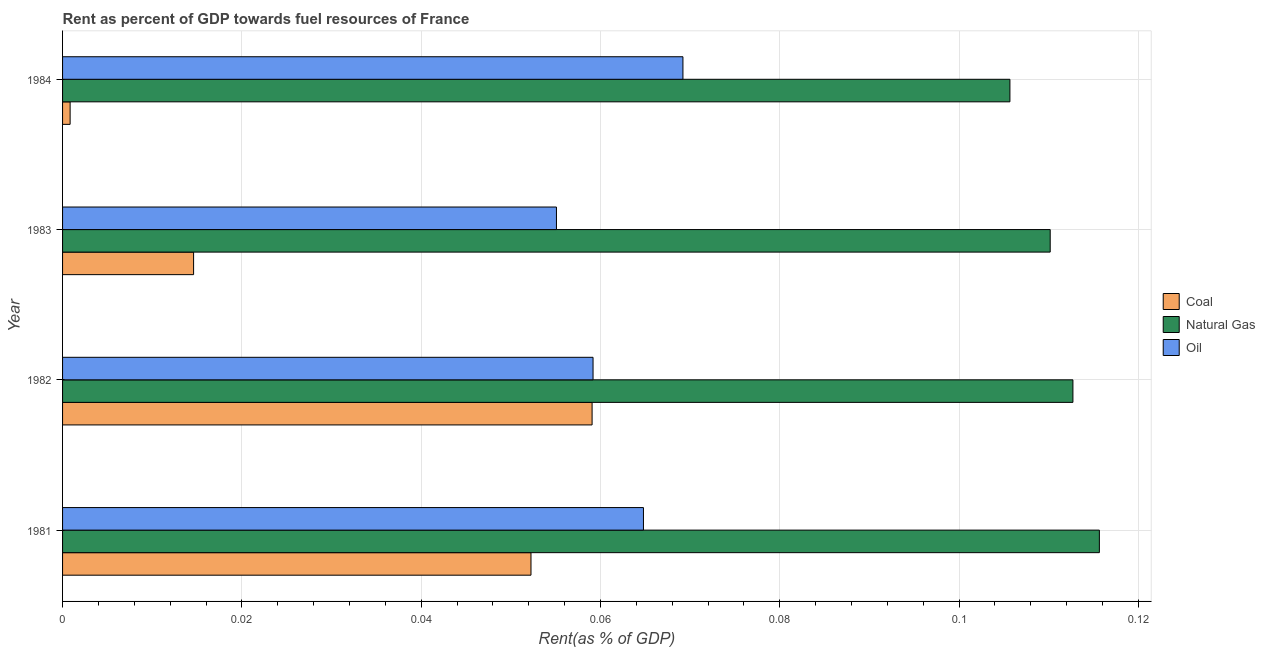How many different coloured bars are there?
Your answer should be compact. 3. How many bars are there on the 2nd tick from the top?
Make the answer very short. 3. What is the label of the 3rd group of bars from the top?
Make the answer very short. 1982. What is the rent towards oil in 1981?
Offer a very short reply. 0.06. Across all years, what is the maximum rent towards natural gas?
Offer a very short reply. 0.12. Across all years, what is the minimum rent towards oil?
Your response must be concise. 0.06. What is the total rent towards natural gas in the graph?
Give a very brief answer. 0.44. What is the difference between the rent towards coal in 1984 and the rent towards natural gas in 1981?
Your answer should be very brief. -0.11. What is the average rent towards coal per year?
Keep it short and to the point. 0.03. In the year 1981, what is the difference between the rent towards oil and rent towards natural gas?
Offer a very short reply. -0.05. In how many years, is the rent towards natural gas greater than 0.052000000000000005 %?
Your answer should be compact. 4. What is the ratio of the rent towards natural gas in 1981 to that in 1984?
Give a very brief answer. 1.09. Is the rent towards natural gas in 1982 less than that in 1983?
Provide a short and direct response. No. Is the difference between the rent towards natural gas in 1982 and 1984 greater than the difference between the rent towards oil in 1982 and 1984?
Ensure brevity in your answer.  Yes. What is the difference between the highest and the second highest rent towards coal?
Your answer should be very brief. 0.01. In how many years, is the rent towards coal greater than the average rent towards coal taken over all years?
Your response must be concise. 2. Is the sum of the rent towards coal in 1983 and 1984 greater than the maximum rent towards oil across all years?
Ensure brevity in your answer.  No. What does the 1st bar from the top in 1981 represents?
Provide a succinct answer. Oil. What does the 1st bar from the bottom in 1984 represents?
Make the answer very short. Coal. Is it the case that in every year, the sum of the rent towards coal and rent towards natural gas is greater than the rent towards oil?
Your answer should be compact. Yes. How many bars are there?
Ensure brevity in your answer.  12. Are all the bars in the graph horizontal?
Give a very brief answer. Yes. How many years are there in the graph?
Your response must be concise. 4. What is the difference between two consecutive major ticks on the X-axis?
Make the answer very short. 0.02. Does the graph contain any zero values?
Ensure brevity in your answer.  No. How are the legend labels stacked?
Your response must be concise. Vertical. What is the title of the graph?
Your answer should be very brief. Rent as percent of GDP towards fuel resources of France. What is the label or title of the X-axis?
Provide a succinct answer. Rent(as % of GDP). What is the label or title of the Y-axis?
Provide a succinct answer. Year. What is the Rent(as % of GDP) of Coal in 1981?
Provide a succinct answer. 0.05. What is the Rent(as % of GDP) of Natural Gas in 1981?
Keep it short and to the point. 0.12. What is the Rent(as % of GDP) in Oil in 1981?
Offer a very short reply. 0.06. What is the Rent(as % of GDP) of Coal in 1982?
Give a very brief answer. 0.06. What is the Rent(as % of GDP) of Natural Gas in 1982?
Provide a short and direct response. 0.11. What is the Rent(as % of GDP) in Oil in 1982?
Your answer should be very brief. 0.06. What is the Rent(as % of GDP) in Coal in 1983?
Make the answer very short. 0.01. What is the Rent(as % of GDP) in Natural Gas in 1983?
Your answer should be very brief. 0.11. What is the Rent(as % of GDP) in Oil in 1983?
Your answer should be very brief. 0.06. What is the Rent(as % of GDP) in Coal in 1984?
Your answer should be compact. 0. What is the Rent(as % of GDP) in Natural Gas in 1984?
Keep it short and to the point. 0.11. What is the Rent(as % of GDP) in Oil in 1984?
Provide a succinct answer. 0.07. Across all years, what is the maximum Rent(as % of GDP) in Coal?
Keep it short and to the point. 0.06. Across all years, what is the maximum Rent(as % of GDP) of Natural Gas?
Your answer should be compact. 0.12. Across all years, what is the maximum Rent(as % of GDP) in Oil?
Make the answer very short. 0.07. Across all years, what is the minimum Rent(as % of GDP) in Coal?
Provide a succinct answer. 0. Across all years, what is the minimum Rent(as % of GDP) of Natural Gas?
Offer a very short reply. 0.11. Across all years, what is the minimum Rent(as % of GDP) of Oil?
Your answer should be compact. 0.06. What is the total Rent(as % of GDP) in Coal in the graph?
Ensure brevity in your answer.  0.13. What is the total Rent(as % of GDP) in Natural Gas in the graph?
Provide a succinct answer. 0.44. What is the total Rent(as % of GDP) in Oil in the graph?
Your answer should be compact. 0.25. What is the difference between the Rent(as % of GDP) in Coal in 1981 and that in 1982?
Your response must be concise. -0.01. What is the difference between the Rent(as % of GDP) of Natural Gas in 1981 and that in 1982?
Your answer should be very brief. 0. What is the difference between the Rent(as % of GDP) of Oil in 1981 and that in 1982?
Your response must be concise. 0.01. What is the difference between the Rent(as % of GDP) in Coal in 1981 and that in 1983?
Keep it short and to the point. 0.04. What is the difference between the Rent(as % of GDP) of Natural Gas in 1981 and that in 1983?
Offer a terse response. 0.01. What is the difference between the Rent(as % of GDP) of Oil in 1981 and that in 1983?
Your answer should be compact. 0.01. What is the difference between the Rent(as % of GDP) in Coal in 1981 and that in 1984?
Your answer should be very brief. 0.05. What is the difference between the Rent(as % of GDP) in Natural Gas in 1981 and that in 1984?
Your answer should be very brief. 0.01. What is the difference between the Rent(as % of GDP) of Oil in 1981 and that in 1984?
Provide a succinct answer. -0. What is the difference between the Rent(as % of GDP) of Coal in 1982 and that in 1983?
Give a very brief answer. 0.04. What is the difference between the Rent(as % of GDP) in Natural Gas in 1982 and that in 1983?
Ensure brevity in your answer.  0. What is the difference between the Rent(as % of GDP) of Oil in 1982 and that in 1983?
Give a very brief answer. 0. What is the difference between the Rent(as % of GDP) of Coal in 1982 and that in 1984?
Provide a short and direct response. 0.06. What is the difference between the Rent(as % of GDP) in Natural Gas in 1982 and that in 1984?
Offer a very short reply. 0.01. What is the difference between the Rent(as % of GDP) of Oil in 1982 and that in 1984?
Your answer should be very brief. -0.01. What is the difference between the Rent(as % of GDP) in Coal in 1983 and that in 1984?
Your answer should be very brief. 0.01. What is the difference between the Rent(as % of GDP) in Natural Gas in 1983 and that in 1984?
Offer a very short reply. 0. What is the difference between the Rent(as % of GDP) in Oil in 1983 and that in 1984?
Provide a short and direct response. -0.01. What is the difference between the Rent(as % of GDP) of Coal in 1981 and the Rent(as % of GDP) of Natural Gas in 1982?
Your response must be concise. -0.06. What is the difference between the Rent(as % of GDP) of Coal in 1981 and the Rent(as % of GDP) of Oil in 1982?
Your response must be concise. -0.01. What is the difference between the Rent(as % of GDP) in Natural Gas in 1981 and the Rent(as % of GDP) in Oil in 1982?
Give a very brief answer. 0.06. What is the difference between the Rent(as % of GDP) of Coal in 1981 and the Rent(as % of GDP) of Natural Gas in 1983?
Your answer should be very brief. -0.06. What is the difference between the Rent(as % of GDP) of Coal in 1981 and the Rent(as % of GDP) of Oil in 1983?
Keep it short and to the point. -0. What is the difference between the Rent(as % of GDP) of Natural Gas in 1981 and the Rent(as % of GDP) of Oil in 1983?
Offer a terse response. 0.06. What is the difference between the Rent(as % of GDP) in Coal in 1981 and the Rent(as % of GDP) in Natural Gas in 1984?
Your response must be concise. -0.05. What is the difference between the Rent(as % of GDP) in Coal in 1981 and the Rent(as % of GDP) in Oil in 1984?
Make the answer very short. -0.02. What is the difference between the Rent(as % of GDP) of Natural Gas in 1981 and the Rent(as % of GDP) of Oil in 1984?
Ensure brevity in your answer.  0.05. What is the difference between the Rent(as % of GDP) in Coal in 1982 and the Rent(as % of GDP) in Natural Gas in 1983?
Offer a very short reply. -0.05. What is the difference between the Rent(as % of GDP) of Coal in 1982 and the Rent(as % of GDP) of Oil in 1983?
Make the answer very short. 0. What is the difference between the Rent(as % of GDP) in Natural Gas in 1982 and the Rent(as % of GDP) in Oil in 1983?
Provide a succinct answer. 0.06. What is the difference between the Rent(as % of GDP) of Coal in 1982 and the Rent(as % of GDP) of Natural Gas in 1984?
Offer a terse response. -0.05. What is the difference between the Rent(as % of GDP) of Coal in 1982 and the Rent(as % of GDP) of Oil in 1984?
Offer a very short reply. -0.01. What is the difference between the Rent(as % of GDP) in Natural Gas in 1982 and the Rent(as % of GDP) in Oil in 1984?
Provide a short and direct response. 0.04. What is the difference between the Rent(as % of GDP) of Coal in 1983 and the Rent(as % of GDP) of Natural Gas in 1984?
Provide a succinct answer. -0.09. What is the difference between the Rent(as % of GDP) in Coal in 1983 and the Rent(as % of GDP) in Oil in 1984?
Ensure brevity in your answer.  -0.05. What is the difference between the Rent(as % of GDP) of Natural Gas in 1983 and the Rent(as % of GDP) of Oil in 1984?
Provide a succinct answer. 0.04. What is the average Rent(as % of GDP) in Coal per year?
Offer a very short reply. 0.03. What is the average Rent(as % of GDP) of Natural Gas per year?
Your response must be concise. 0.11. What is the average Rent(as % of GDP) of Oil per year?
Your answer should be compact. 0.06. In the year 1981, what is the difference between the Rent(as % of GDP) in Coal and Rent(as % of GDP) in Natural Gas?
Ensure brevity in your answer.  -0.06. In the year 1981, what is the difference between the Rent(as % of GDP) of Coal and Rent(as % of GDP) of Oil?
Provide a succinct answer. -0.01. In the year 1981, what is the difference between the Rent(as % of GDP) in Natural Gas and Rent(as % of GDP) in Oil?
Ensure brevity in your answer.  0.05. In the year 1982, what is the difference between the Rent(as % of GDP) of Coal and Rent(as % of GDP) of Natural Gas?
Your response must be concise. -0.05. In the year 1982, what is the difference between the Rent(as % of GDP) in Coal and Rent(as % of GDP) in Oil?
Offer a very short reply. -0. In the year 1982, what is the difference between the Rent(as % of GDP) in Natural Gas and Rent(as % of GDP) in Oil?
Ensure brevity in your answer.  0.05. In the year 1983, what is the difference between the Rent(as % of GDP) of Coal and Rent(as % of GDP) of Natural Gas?
Make the answer very short. -0.1. In the year 1983, what is the difference between the Rent(as % of GDP) in Coal and Rent(as % of GDP) in Oil?
Your answer should be compact. -0.04. In the year 1983, what is the difference between the Rent(as % of GDP) in Natural Gas and Rent(as % of GDP) in Oil?
Make the answer very short. 0.06. In the year 1984, what is the difference between the Rent(as % of GDP) in Coal and Rent(as % of GDP) in Natural Gas?
Provide a succinct answer. -0.1. In the year 1984, what is the difference between the Rent(as % of GDP) of Coal and Rent(as % of GDP) of Oil?
Make the answer very short. -0.07. In the year 1984, what is the difference between the Rent(as % of GDP) of Natural Gas and Rent(as % of GDP) of Oil?
Your response must be concise. 0.04. What is the ratio of the Rent(as % of GDP) in Coal in 1981 to that in 1982?
Offer a terse response. 0.88. What is the ratio of the Rent(as % of GDP) in Natural Gas in 1981 to that in 1982?
Offer a terse response. 1.03. What is the ratio of the Rent(as % of GDP) in Oil in 1981 to that in 1982?
Provide a short and direct response. 1.09. What is the ratio of the Rent(as % of GDP) of Coal in 1981 to that in 1983?
Your answer should be compact. 3.57. What is the ratio of the Rent(as % of GDP) in Natural Gas in 1981 to that in 1983?
Offer a very short reply. 1.05. What is the ratio of the Rent(as % of GDP) of Oil in 1981 to that in 1983?
Offer a very short reply. 1.18. What is the ratio of the Rent(as % of GDP) in Coal in 1981 to that in 1984?
Provide a succinct answer. 61.97. What is the ratio of the Rent(as % of GDP) in Natural Gas in 1981 to that in 1984?
Your answer should be very brief. 1.09. What is the ratio of the Rent(as % of GDP) of Oil in 1981 to that in 1984?
Give a very brief answer. 0.94. What is the ratio of the Rent(as % of GDP) of Coal in 1982 to that in 1983?
Your response must be concise. 4.04. What is the ratio of the Rent(as % of GDP) in Oil in 1982 to that in 1983?
Ensure brevity in your answer.  1.07. What is the ratio of the Rent(as % of GDP) of Coal in 1982 to that in 1984?
Provide a succinct answer. 70.06. What is the ratio of the Rent(as % of GDP) in Natural Gas in 1982 to that in 1984?
Offer a terse response. 1.07. What is the ratio of the Rent(as % of GDP) in Oil in 1982 to that in 1984?
Provide a succinct answer. 0.86. What is the ratio of the Rent(as % of GDP) in Coal in 1983 to that in 1984?
Your answer should be compact. 17.34. What is the ratio of the Rent(as % of GDP) in Natural Gas in 1983 to that in 1984?
Offer a terse response. 1.04. What is the ratio of the Rent(as % of GDP) in Oil in 1983 to that in 1984?
Your answer should be compact. 0.8. What is the difference between the highest and the second highest Rent(as % of GDP) in Coal?
Offer a terse response. 0.01. What is the difference between the highest and the second highest Rent(as % of GDP) in Natural Gas?
Give a very brief answer. 0. What is the difference between the highest and the second highest Rent(as % of GDP) in Oil?
Offer a very short reply. 0. What is the difference between the highest and the lowest Rent(as % of GDP) in Coal?
Provide a succinct answer. 0.06. What is the difference between the highest and the lowest Rent(as % of GDP) of Oil?
Your answer should be compact. 0.01. 